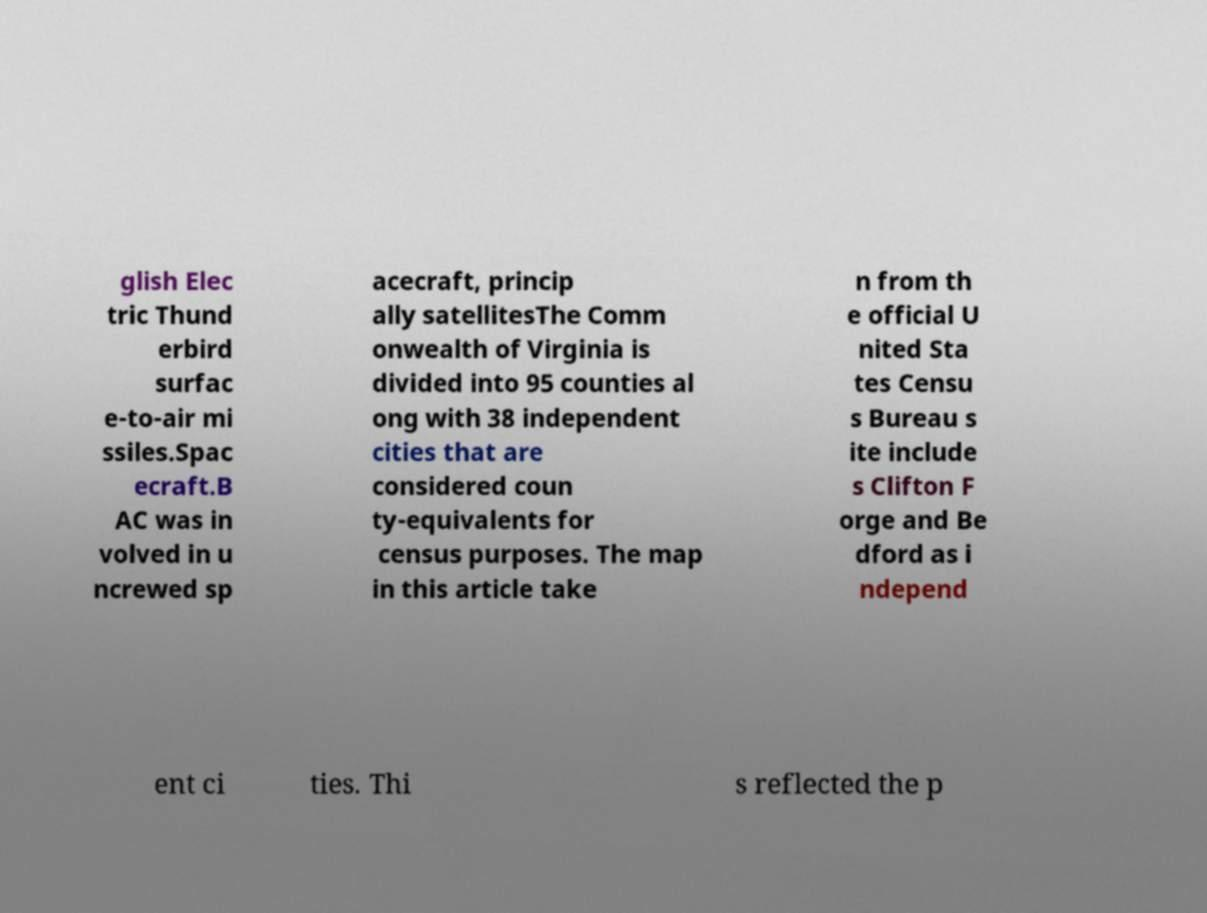I need the written content from this picture converted into text. Can you do that? glish Elec tric Thund erbird surfac e-to-air mi ssiles.Spac ecraft.B AC was in volved in u ncrewed sp acecraft, princip ally satellitesThe Comm onwealth of Virginia is divided into 95 counties al ong with 38 independent cities that are considered coun ty-equivalents for census purposes. The map in this article take n from th e official U nited Sta tes Censu s Bureau s ite include s Clifton F orge and Be dford as i ndepend ent ci ties. Thi s reflected the p 